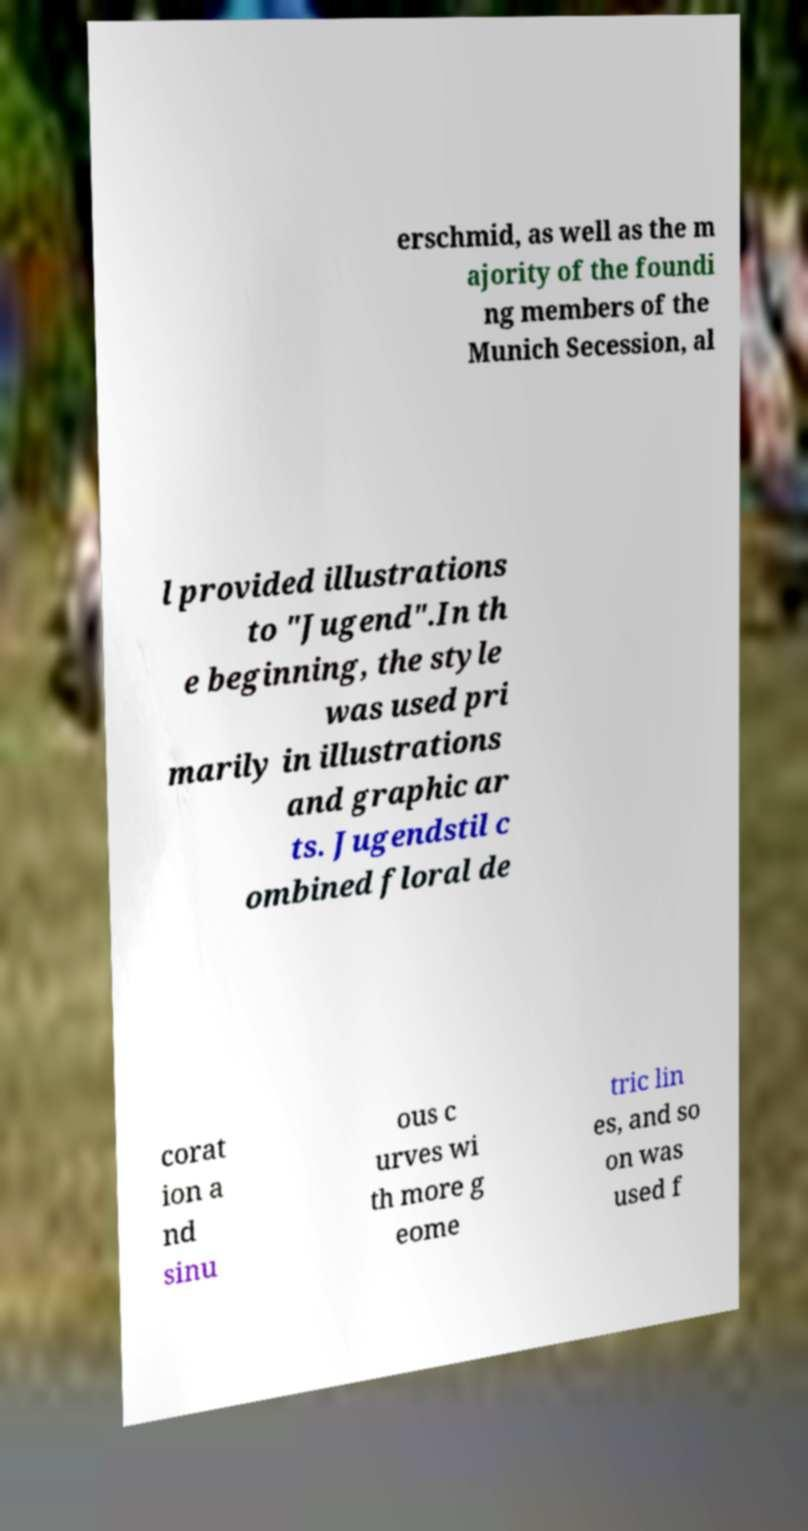There's text embedded in this image that I need extracted. Can you transcribe it verbatim? erschmid, as well as the m ajority of the foundi ng members of the Munich Secession, al l provided illustrations to "Jugend".In th e beginning, the style was used pri marily in illustrations and graphic ar ts. Jugendstil c ombined floral de corat ion a nd sinu ous c urves wi th more g eome tric lin es, and so on was used f 